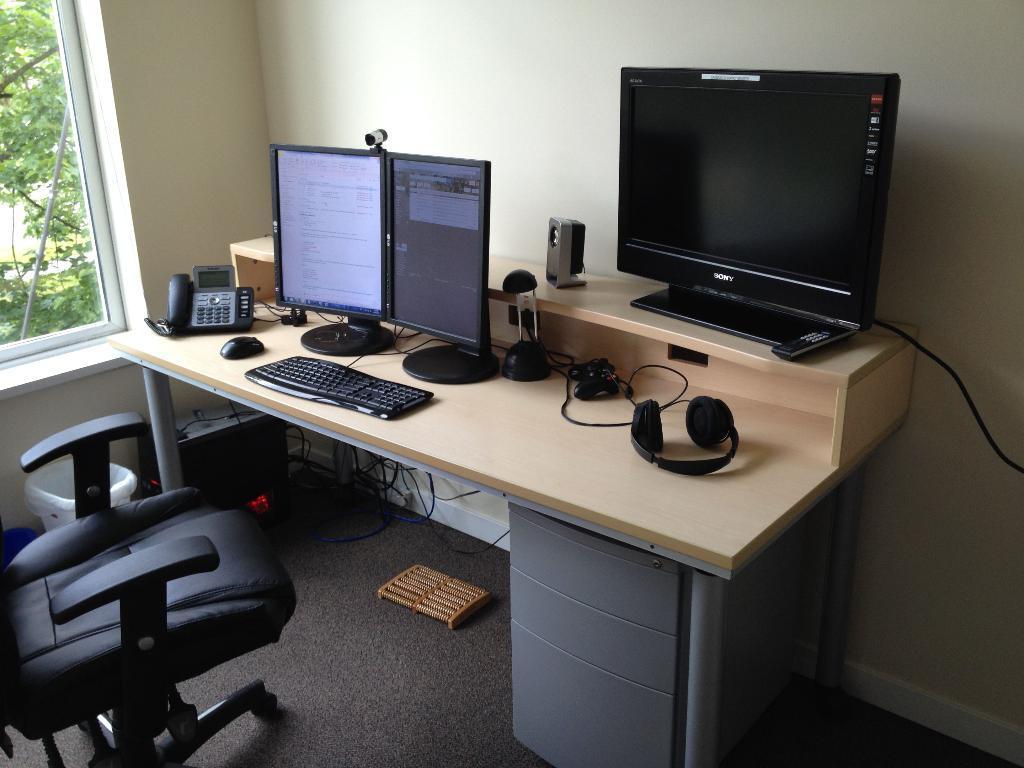How would you summarize this image in a sentence or two? In this picture there is a table. On the table headphones, monitors, keyboard, telephone are there. Beside the table there is a chair. On the top left of the image there is a window. Through the window I can see the outside view. 